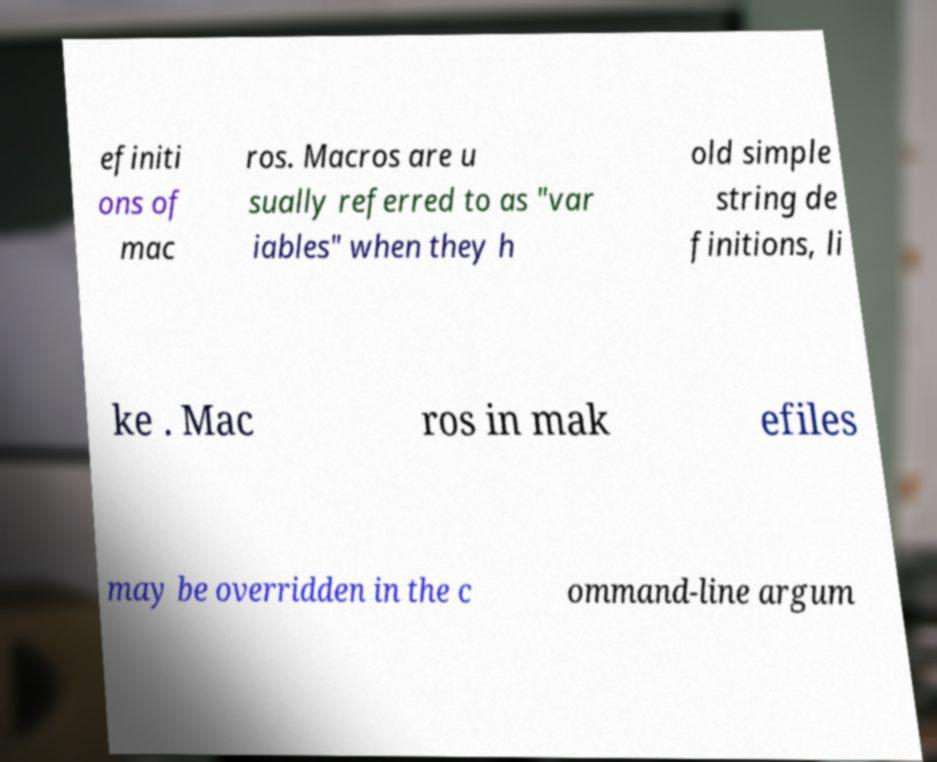Please read and relay the text visible in this image. What does it say? efiniti ons of mac ros. Macros are u sually referred to as "var iables" when they h old simple string de finitions, li ke . Mac ros in mak efiles may be overridden in the c ommand-line argum 